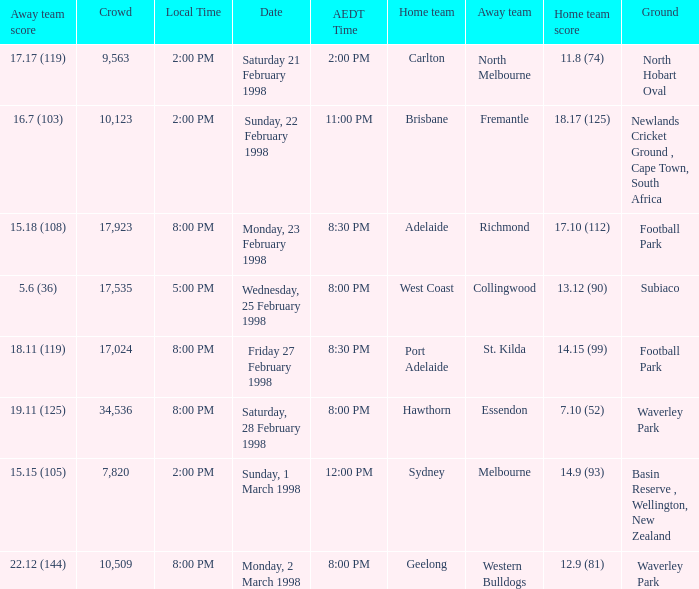Name the Away team which has a Ground of waverley park, and a Home team of hawthorn? Essendon. 